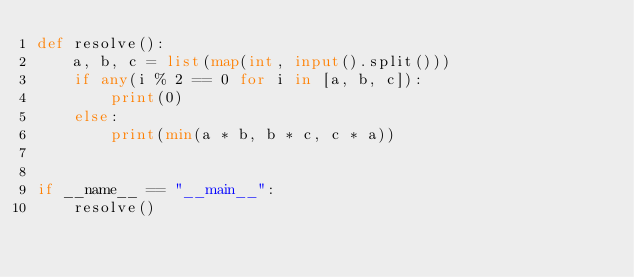Convert code to text. <code><loc_0><loc_0><loc_500><loc_500><_Python_>def resolve():
    a, b, c = list(map(int, input().split()))
    if any(i % 2 == 0 for i in [a, b, c]):
        print(0)
    else:
        print(min(a * b, b * c, c * a))


if __name__ == "__main__":
    resolve()
</code> 